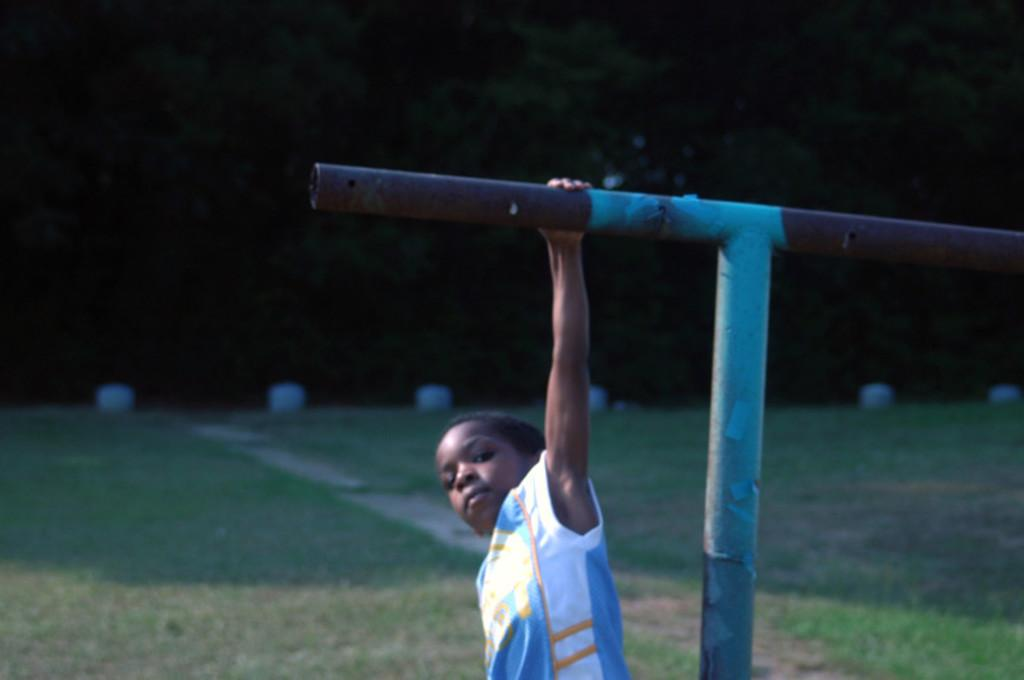What is the main subject of the image? The main subject of the image is a kid. What is the kid holding in his left hand? The kid is holding a metal rod in his left hand. What type of surface is in front of the kid? There is grass on the surface in front of the kid. What can be seen in the background of the image? There are trees in the background of the image. What color is the paint on the pump in the image? There is no pump or paint present in the image. What type of noise can be heard coming from the trees in the background? There is no indication of any noise in the image, and the trees are not described as making any sounds. 